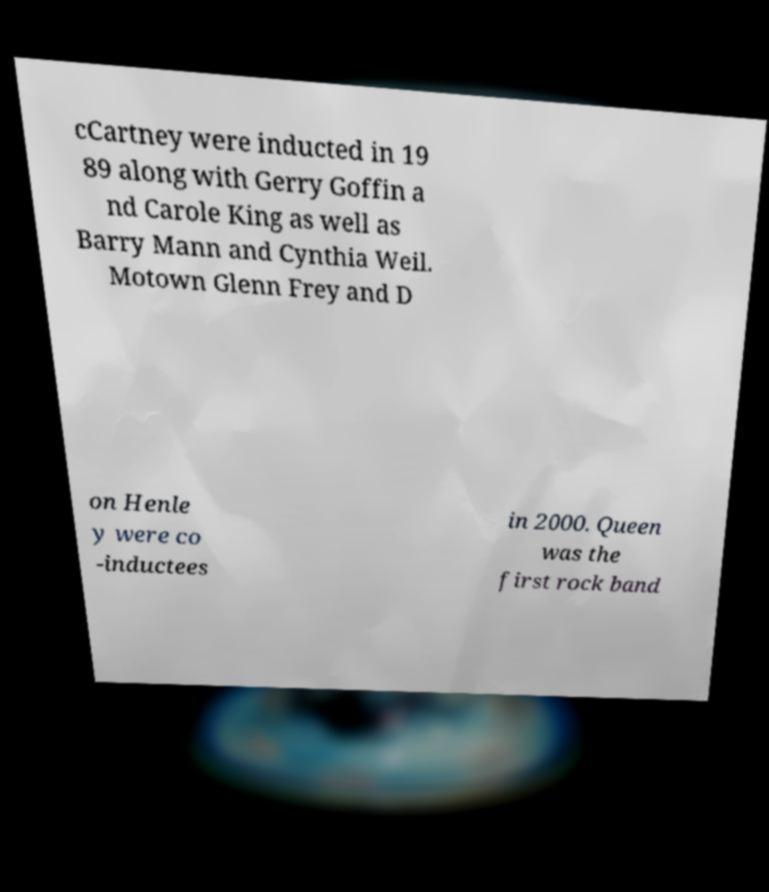There's text embedded in this image that I need extracted. Can you transcribe it verbatim? cCartney were inducted in 19 89 along with Gerry Goffin a nd Carole King as well as Barry Mann and Cynthia Weil. Motown Glenn Frey and D on Henle y were co -inductees in 2000. Queen was the first rock band 